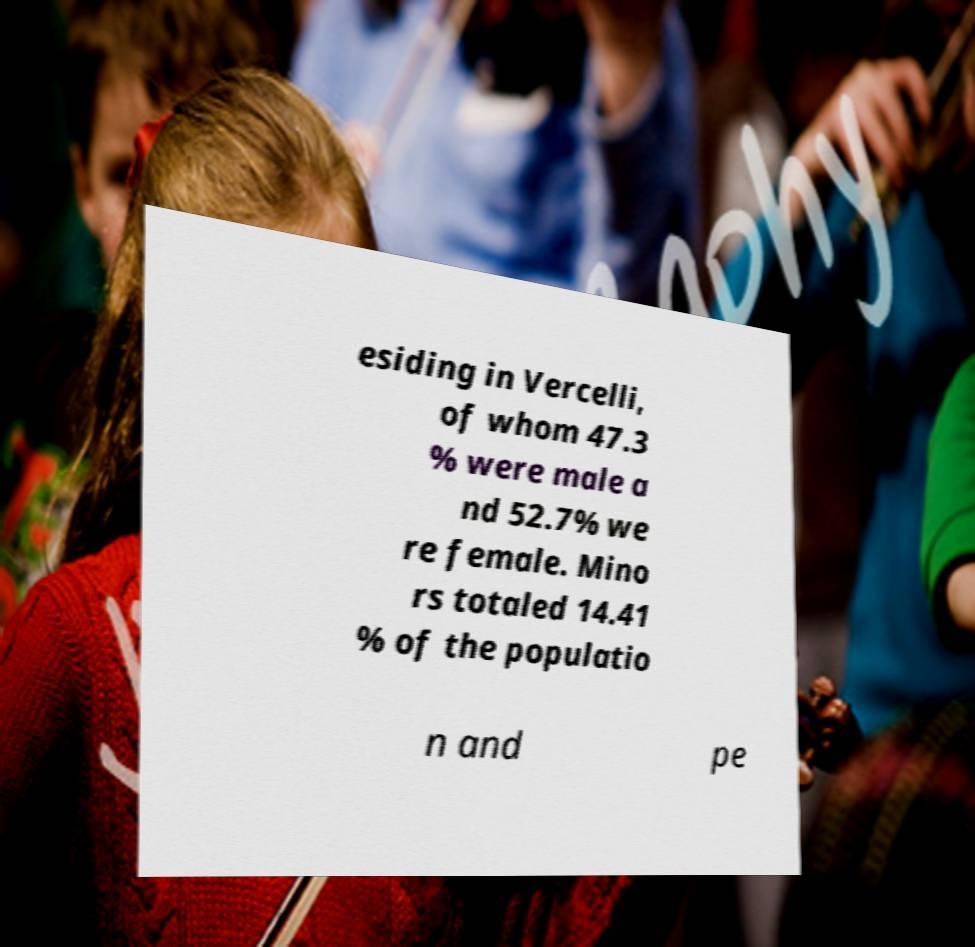Please read and relay the text visible in this image. What does it say? esiding in Vercelli, of whom 47.3 % were male a nd 52.7% we re female. Mino rs totaled 14.41 % of the populatio n and pe 